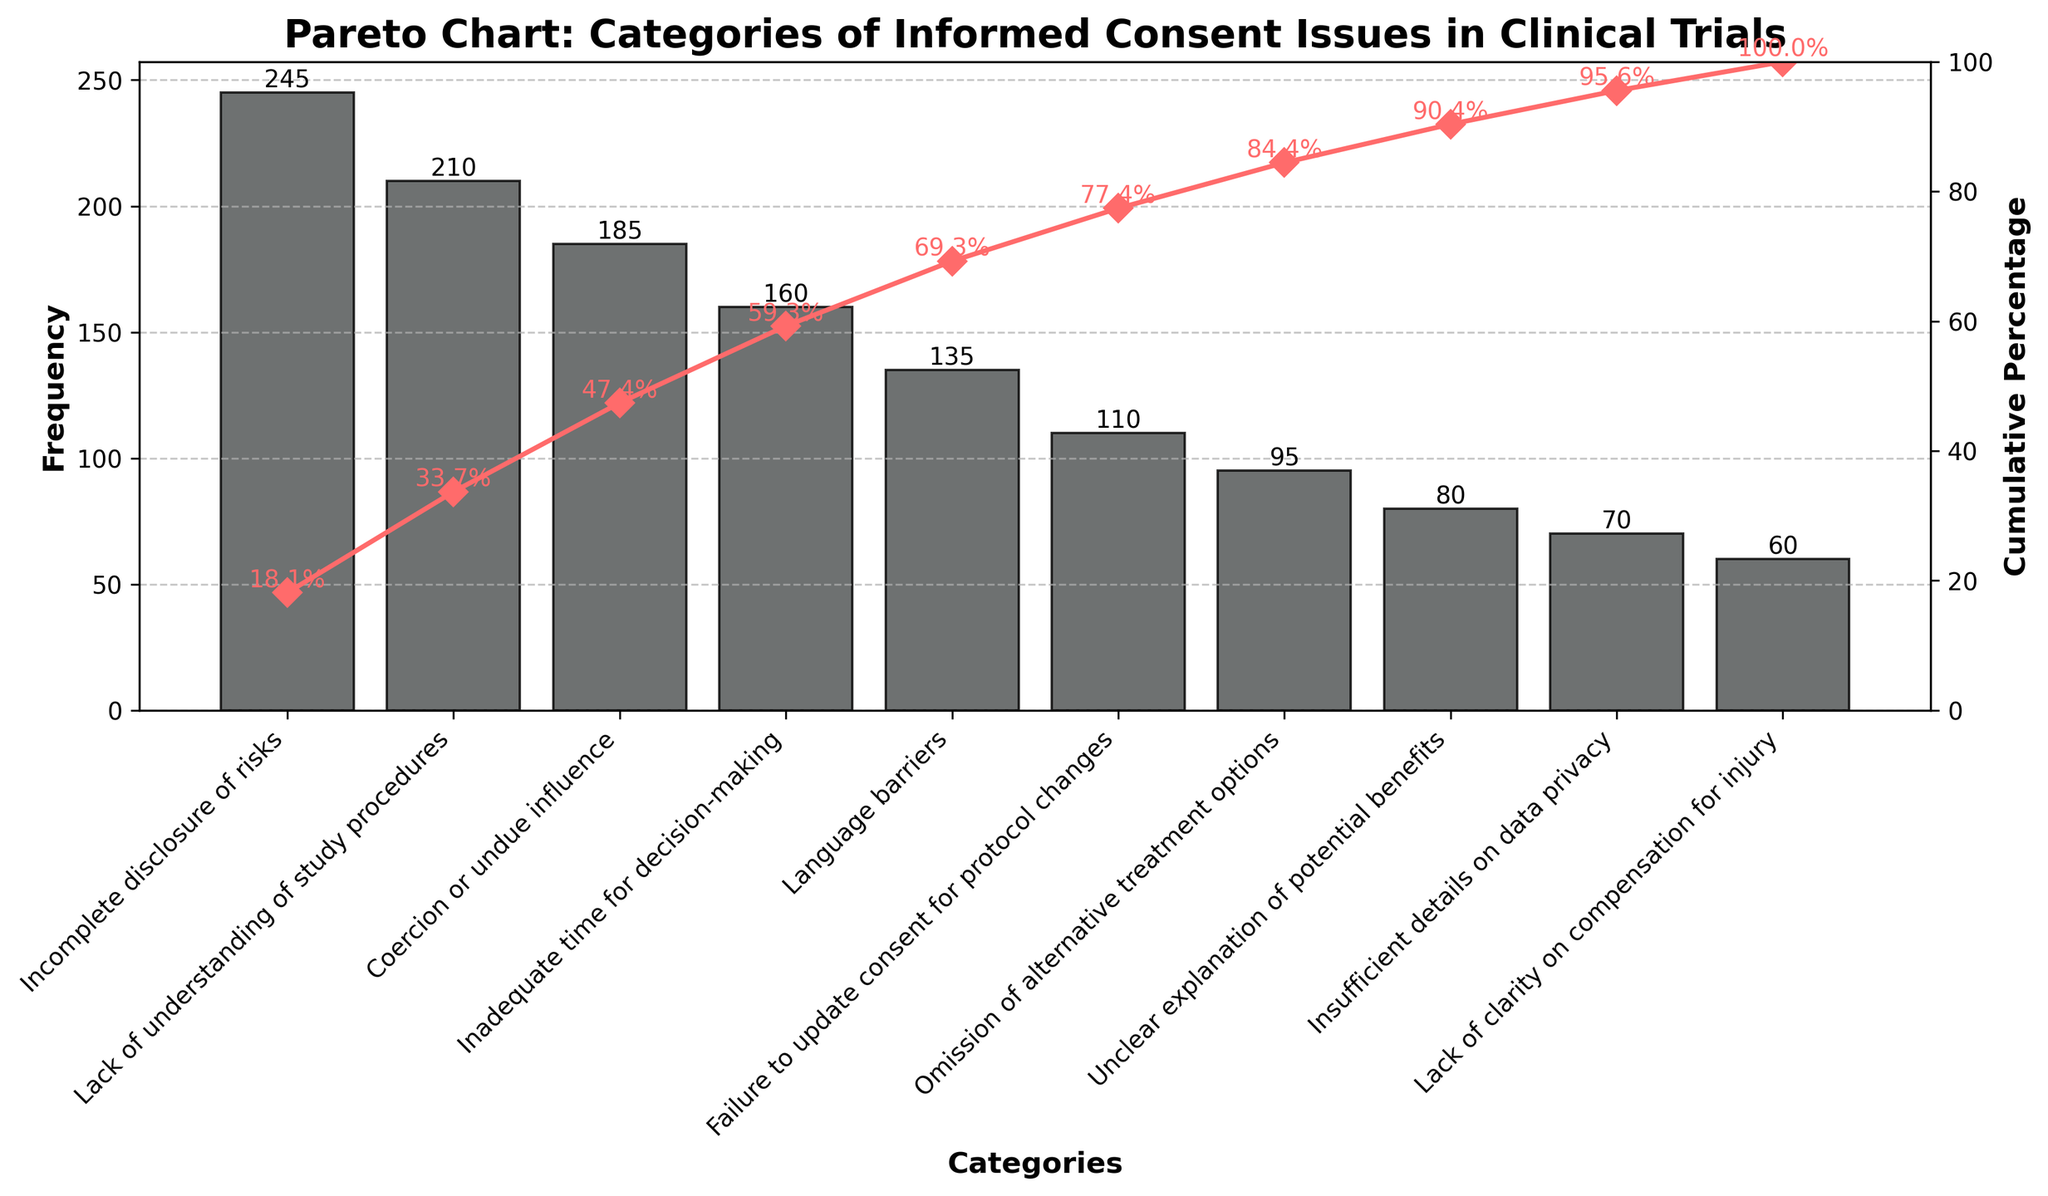What's the title of the chart? The title of the chart is typically located at the top of the figure and describes its main subject.
Answer: Pareto Chart: Categories of Informed Consent Issues in Clinical Trials How many categories are represented in the chart? Count the number of distinct categories listed on the x-axis of the chart.
Answer: 10 Which category has the highest frequency? Look at the bar chart where the tallest bar represents the category with the highest frequency.
Answer: Incomplete disclosure of risks What is the cumulative percentage after the top three categories? Sum the first three frequencies (top three bars) and divide by the total sum of all frequencies, then multiply by 100 to convert to a percentage. Step-by-step: 245 (Incomplete disclosure of risks) + 210 (Lack of understanding of study procedures) + 185 (Coercion or undue influence) = 640. The total sum of frequencies is 1340. Cumulative percentage = (640 / 1340) * 100 = 47.8%
Answer: 47.8% Which category is ranked fifth in terms of frequency? Identify the fifth category based on the sorted frequencies on the x-axis.
Answer: Language barriers What's the color of the bars and the cumulative percentage line? Identify the colors used in the bars and cumulative percentage line by visually inspecting them.
Answer: Bars: gray, Cumulative Percentage Line: red How much less frequent is "Failure to update consent for protocol changes" compared to "Lack of understanding of study procedures"? Subtract the frequency of "Failure to update consent for protocol changes" from "Lack of understanding of study procedures". Step-by-step: 210 (Lack of understanding of study procedures) - 110 (Failure to update consent for protocol changes) = 100
Answer: 100 What is the frequency difference between the category with the highest frequency and the lowest frequency? Subtract the smallest frequency from the highest frequency. Step-by-step: 245 (highest frequency) - 60 (lowest frequency) = 185
Answer: 185 Which categories have a cumulative percentage below 50%? Check the cumulative percentage values plotted on the chart and list the categories whose cumulative percentages fall below 50%. The cumulative percentages listed step-by-step are 18.3%, 34.0%, and 47.8%, corresponding to the categories "Incomplete disclosure of risks", "Lack of understanding of study procedures", and "Coercion or undue influence".
Answer: Incomplete disclosure of risks; Lack of understanding of study procedures; Coercion or undue influence What percentage of issues fall into the top two categories? Sum the frequencies of the top two categories and divide by the total frequencies, then multiply by 100. Step-by-step: 245 + 210 = 455. Total is 1340. Percentage = (455 / 1340) * 100 = 33.96%.
Answer: 34% 